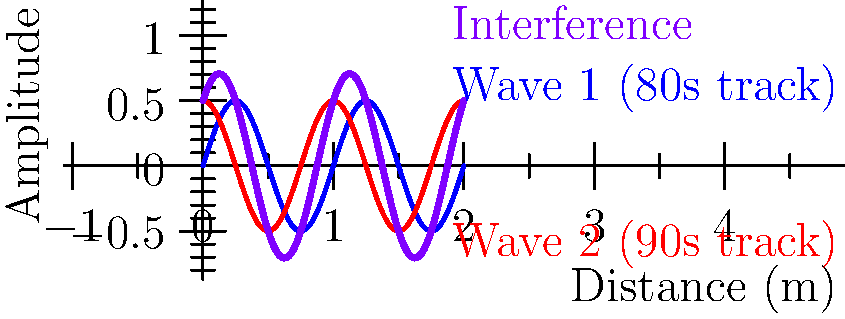As a DJ specializing in 80s and 90s hits, you're experimenting with playing two tracks simultaneously through separate speakers. The sound waves from these tracks can be modeled as shown in the graph, where the blue wave represents an 80s track and the red wave a 90s track. If both tracks have the same frequency but are out of phase by $\frac{\pi}{2}$ radians, what is the maximum amplitude of the resulting interference pattern (purple curve)? To solve this problem, let's follow these steps:

1) The blue wave (80s track) can be represented as:
   $$y_1 = 0.5 \sin(2\pi x)$$

2) The red wave (90s track), phase-shifted by $\frac{\pi}{2}$, can be represented as:
   $$y_2 = 0.5 \sin(2\pi x + \frac{\pi}{2})$$

3) The resulting interference pattern is the sum of these two waves:
   $$y = y_1 + y_2 = 0.5 \sin(2\pi x) + 0.5 \sin(2\pi x + \frac{\pi}{2})$$

4) To find the maximum amplitude, we can use the trigonometric identity:
   $$\sin A + \sin B = 2 \sin(\frac{A+B}{2}) \cos(\frac{A-B}{2})$$

5) In our case, $A = 2\pi x$ and $B = 2\pi x + \frac{\pi}{2}$. Substituting:
   $$y = 2 \cdot 0.5 \sin(2\pi x + \frac{\pi}{4}) \cos(-\frac{\pi}{4})$$

6) Simplify:
   $$y = \sin(2\pi x + \frac{\pi}{4}) \cos(\frac{\pi}{4})$$

7) The maximum amplitude occurs when $\sin(2\pi x + \frac{\pi}{4}) = 1$. At this point:
   $$y_{max} = \cos(\frac{\pi}{4}) = \frac{\sqrt{2}}{2}$$

8) Therefore, the maximum amplitude of the interference pattern is $\frac{\sqrt{2}}{2} \approx 0.707$.
Answer: $\frac{\sqrt{2}}{2}$ 